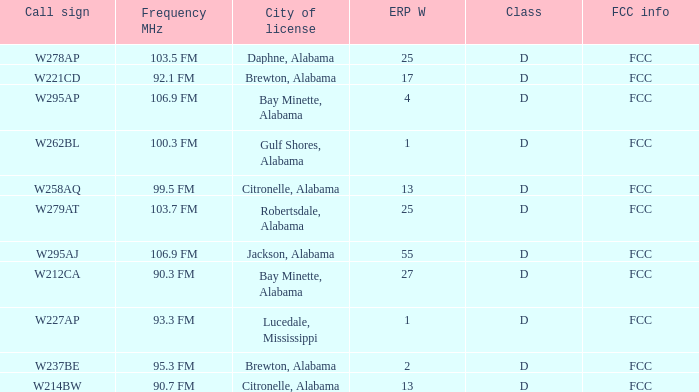Name the call sign for ERP W of 27 W212CA. 